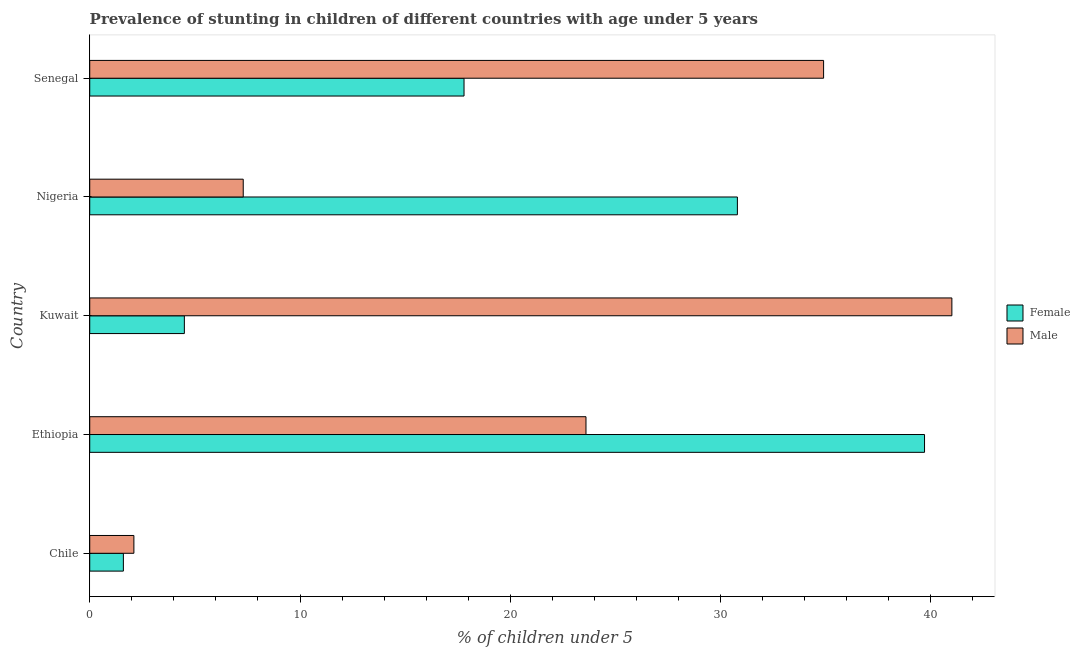How many different coloured bars are there?
Make the answer very short. 2. Are the number of bars per tick equal to the number of legend labels?
Make the answer very short. Yes. Are the number of bars on each tick of the Y-axis equal?
Your answer should be compact. Yes. What is the label of the 1st group of bars from the top?
Provide a short and direct response. Senegal. In how many cases, is the number of bars for a given country not equal to the number of legend labels?
Give a very brief answer. 0. What is the percentage of stunted female children in Nigeria?
Provide a short and direct response. 30.8. Across all countries, what is the maximum percentage of stunted male children?
Offer a very short reply. 41. Across all countries, what is the minimum percentage of stunted male children?
Your answer should be compact. 2.1. In which country was the percentage of stunted female children maximum?
Keep it short and to the point. Ethiopia. In which country was the percentage of stunted female children minimum?
Ensure brevity in your answer.  Chile. What is the total percentage of stunted male children in the graph?
Your response must be concise. 108.9. What is the difference between the percentage of stunted male children in Nigeria and the percentage of stunted female children in Chile?
Your answer should be very brief. 5.7. What is the average percentage of stunted male children per country?
Your response must be concise. 21.78. What is the difference between the percentage of stunted male children and percentage of stunted female children in Chile?
Your response must be concise. 0.5. In how many countries, is the percentage of stunted male children greater than 4 %?
Your answer should be compact. 4. What is the ratio of the percentage of stunted male children in Ethiopia to that in Senegal?
Offer a very short reply. 0.68. Is the percentage of stunted female children in Chile less than that in Nigeria?
Your response must be concise. Yes. Is the difference between the percentage of stunted female children in Ethiopia and Nigeria greater than the difference between the percentage of stunted male children in Ethiopia and Nigeria?
Offer a terse response. No. What is the difference between the highest and the second highest percentage of stunted male children?
Give a very brief answer. 6.1. What is the difference between the highest and the lowest percentage of stunted male children?
Give a very brief answer. 38.9. In how many countries, is the percentage of stunted female children greater than the average percentage of stunted female children taken over all countries?
Provide a succinct answer. 2. What does the 1st bar from the top in Nigeria represents?
Make the answer very short. Male. What does the 2nd bar from the bottom in Chile represents?
Provide a succinct answer. Male. How many countries are there in the graph?
Your answer should be very brief. 5. Are the values on the major ticks of X-axis written in scientific E-notation?
Your answer should be compact. No. Does the graph contain grids?
Your answer should be very brief. No. Where does the legend appear in the graph?
Provide a succinct answer. Center right. How many legend labels are there?
Your answer should be very brief. 2. What is the title of the graph?
Keep it short and to the point. Prevalence of stunting in children of different countries with age under 5 years. What is the label or title of the X-axis?
Provide a succinct answer.  % of children under 5. What is the label or title of the Y-axis?
Give a very brief answer. Country. What is the  % of children under 5 in Female in Chile?
Provide a short and direct response. 1.6. What is the  % of children under 5 in Male in Chile?
Offer a terse response. 2.1. What is the  % of children under 5 of Female in Ethiopia?
Provide a succinct answer. 39.7. What is the  % of children under 5 of Male in Ethiopia?
Your answer should be very brief. 23.6. What is the  % of children under 5 of Female in Kuwait?
Your response must be concise. 4.5. What is the  % of children under 5 of Male in Kuwait?
Offer a very short reply. 41. What is the  % of children under 5 in Female in Nigeria?
Make the answer very short. 30.8. What is the  % of children under 5 in Male in Nigeria?
Ensure brevity in your answer.  7.3. What is the  % of children under 5 in Female in Senegal?
Your answer should be very brief. 17.8. What is the  % of children under 5 in Male in Senegal?
Your answer should be compact. 34.9. Across all countries, what is the maximum  % of children under 5 of Female?
Provide a short and direct response. 39.7. Across all countries, what is the maximum  % of children under 5 of Male?
Your answer should be compact. 41. Across all countries, what is the minimum  % of children under 5 of Female?
Offer a terse response. 1.6. Across all countries, what is the minimum  % of children under 5 in Male?
Keep it short and to the point. 2.1. What is the total  % of children under 5 of Female in the graph?
Offer a terse response. 94.4. What is the total  % of children under 5 of Male in the graph?
Ensure brevity in your answer.  108.9. What is the difference between the  % of children under 5 in Female in Chile and that in Ethiopia?
Offer a very short reply. -38.1. What is the difference between the  % of children under 5 of Male in Chile and that in Ethiopia?
Give a very brief answer. -21.5. What is the difference between the  % of children under 5 in Female in Chile and that in Kuwait?
Provide a succinct answer. -2.9. What is the difference between the  % of children under 5 of Male in Chile and that in Kuwait?
Provide a short and direct response. -38.9. What is the difference between the  % of children under 5 of Female in Chile and that in Nigeria?
Offer a very short reply. -29.2. What is the difference between the  % of children under 5 of Male in Chile and that in Nigeria?
Provide a short and direct response. -5.2. What is the difference between the  % of children under 5 of Female in Chile and that in Senegal?
Provide a short and direct response. -16.2. What is the difference between the  % of children under 5 in Male in Chile and that in Senegal?
Make the answer very short. -32.8. What is the difference between the  % of children under 5 in Female in Ethiopia and that in Kuwait?
Give a very brief answer. 35.2. What is the difference between the  % of children under 5 of Male in Ethiopia and that in Kuwait?
Ensure brevity in your answer.  -17.4. What is the difference between the  % of children under 5 in Female in Ethiopia and that in Nigeria?
Make the answer very short. 8.9. What is the difference between the  % of children under 5 of Female in Ethiopia and that in Senegal?
Give a very brief answer. 21.9. What is the difference between the  % of children under 5 of Male in Ethiopia and that in Senegal?
Ensure brevity in your answer.  -11.3. What is the difference between the  % of children under 5 of Female in Kuwait and that in Nigeria?
Give a very brief answer. -26.3. What is the difference between the  % of children under 5 in Male in Kuwait and that in Nigeria?
Provide a short and direct response. 33.7. What is the difference between the  % of children under 5 in Female in Nigeria and that in Senegal?
Ensure brevity in your answer.  13. What is the difference between the  % of children under 5 in Male in Nigeria and that in Senegal?
Offer a very short reply. -27.6. What is the difference between the  % of children under 5 in Female in Chile and the  % of children under 5 in Male in Kuwait?
Give a very brief answer. -39.4. What is the difference between the  % of children under 5 of Female in Chile and the  % of children under 5 of Male in Senegal?
Give a very brief answer. -33.3. What is the difference between the  % of children under 5 of Female in Ethiopia and the  % of children under 5 of Male in Kuwait?
Your answer should be compact. -1.3. What is the difference between the  % of children under 5 of Female in Ethiopia and the  % of children under 5 of Male in Nigeria?
Make the answer very short. 32.4. What is the difference between the  % of children under 5 of Female in Kuwait and the  % of children under 5 of Male in Senegal?
Your response must be concise. -30.4. What is the difference between the  % of children under 5 of Female in Nigeria and the  % of children under 5 of Male in Senegal?
Your answer should be compact. -4.1. What is the average  % of children under 5 in Female per country?
Offer a very short reply. 18.88. What is the average  % of children under 5 in Male per country?
Your response must be concise. 21.78. What is the difference between the  % of children under 5 of Female and  % of children under 5 of Male in Ethiopia?
Offer a very short reply. 16.1. What is the difference between the  % of children under 5 of Female and  % of children under 5 of Male in Kuwait?
Keep it short and to the point. -36.5. What is the difference between the  % of children under 5 in Female and  % of children under 5 in Male in Nigeria?
Make the answer very short. 23.5. What is the difference between the  % of children under 5 in Female and  % of children under 5 in Male in Senegal?
Provide a short and direct response. -17.1. What is the ratio of the  % of children under 5 of Female in Chile to that in Ethiopia?
Provide a succinct answer. 0.04. What is the ratio of the  % of children under 5 in Male in Chile to that in Ethiopia?
Keep it short and to the point. 0.09. What is the ratio of the  % of children under 5 in Female in Chile to that in Kuwait?
Give a very brief answer. 0.36. What is the ratio of the  % of children under 5 in Male in Chile to that in Kuwait?
Provide a short and direct response. 0.05. What is the ratio of the  % of children under 5 of Female in Chile to that in Nigeria?
Your response must be concise. 0.05. What is the ratio of the  % of children under 5 of Male in Chile to that in Nigeria?
Ensure brevity in your answer.  0.29. What is the ratio of the  % of children under 5 in Female in Chile to that in Senegal?
Provide a short and direct response. 0.09. What is the ratio of the  % of children under 5 in Male in Chile to that in Senegal?
Offer a terse response. 0.06. What is the ratio of the  % of children under 5 in Female in Ethiopia to that in Kuwait?
Provide a short and direct response. 8.82. What is the ratio of the  % of children under 5 in Male in Ethiopia to that in Kuwait?
Offer a very short reply. 0.58. What is the ratio of the  % of children under 5 in Female in Ethiopia to that in Nigeria?
Keep it short and to the point. 1.29. What is the ratio of the  % of children under 5 in Male in Ethiopia to that in Nigeria?
Provide a short and direct response. 3.23. What is the ratio of the  % of children under 5 in Female in Ethiopia to that in Senegal?
Provide a short and direct response. 2.23. What is the ratio of the  % of children under 5 of Male in Ethiopia to that in Senegal?
Make the answer very short. 0.68. What is the ratio of the  % of children under 5 of Female in Kuwait to that in Nigeria?
Make the answer very short. 0.15. What is the ratio of the  % of children under 5 of Male in Kuwait to that in Nigeria?
Offer a terse response. 5.62. What is the ratio of the  % of children under 5 of Female in Kuwait to that in Senegal?
Your answer should be compact. 0.25. What is the ratio of the  % of children under 5 in Male in Kuwait to that in Senegal?
Provide a succinct answer. 1.17. What is the ratio of the  % of children under 5 of Female in Nigeria to that in Senegal?
Your answer should be very brief. 1.73. What is the ratio of the  % of children under 5 of Male in Nigeria to that in Senegal?
Give a very brief answer. 0.21. What is the difference between the highest and the second highest  % of children under 5 in Male?
Ensure brevity in your answer.  6.1. What is the difference between the highest and the lowest  % of children under 5 of Female?
Your answer should be very brief. 38.1. What is the difference between the highest and the lowest  % of children under 5 in Male?
Your response must be concise. 38.9. 